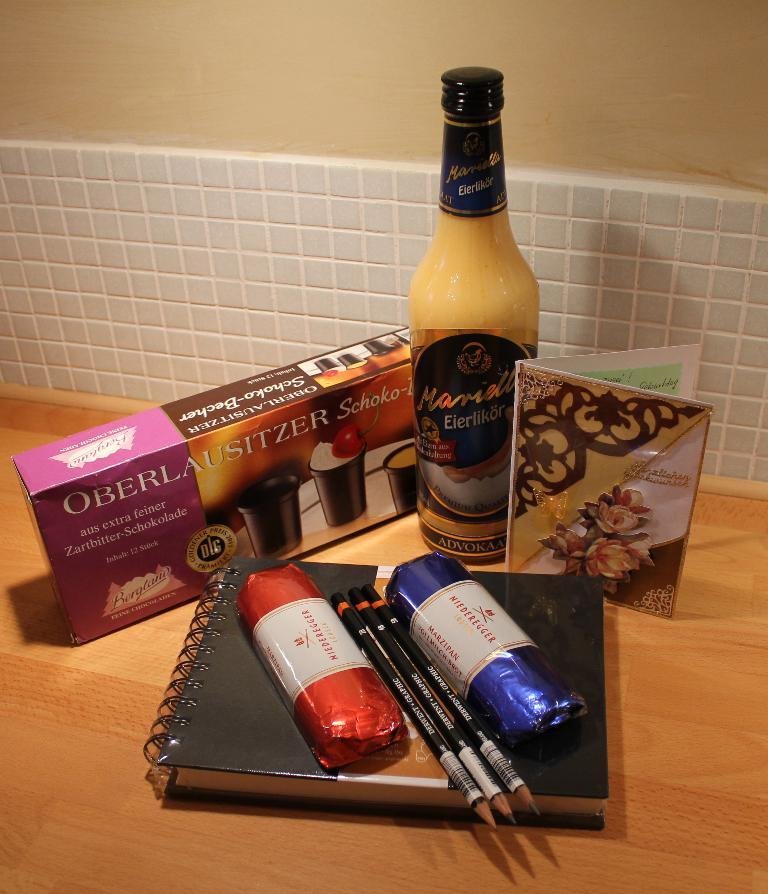Provide a one-sentence caption for the provided image. two packages of Niederegger marzipan set on a book laying in front of a bottle and a package of chocolate cups. 